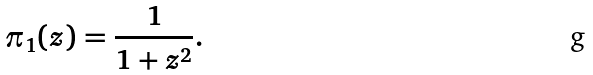<formula> <loc_0><loc_0><loc_500><loc_500>\pi _ { 1 } ( z ) = \frac { 1 } { 1 + z ^ { 2 } } .</formula> 